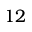Convert formula to latex. <formula><loc_0><loc_0><loc_500><loc_500>1 2</formula> 